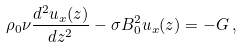<formula> <loc_0><loc_0><loc_500><loc_500>\rho _ { 0 } \nu \frac { d ^ { 2 } u _ { x } ( z ) } { d z ^ { 2 } } - \sigma B _ { 0 } ^ { 2 } u _ { x } ( z ) = - G \, ,</formula> 